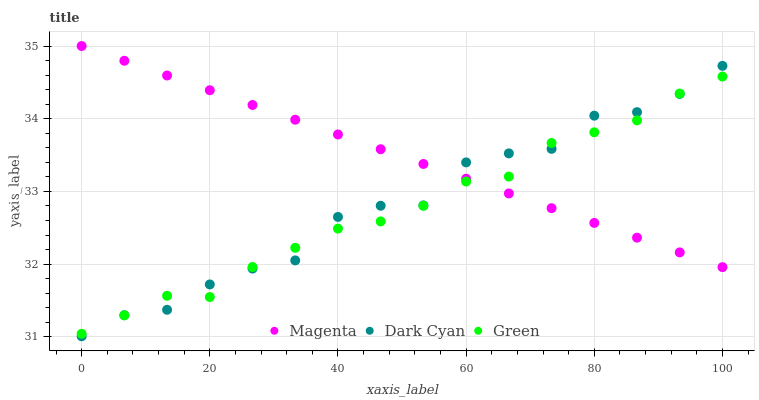Does Green have the minimum area under the curve?
Answer yes or no. Yes. Does Magenta have the maximum area under the curve?
Answer yes or no. Yes. Does Magenta have the minimum area under the curve?
Answer yes or no. No. Does Green have the maximum area under the curve?
Answer yes or no. No. Is Magenta the smoothest?
Answer yes or no. Yes. Is Dark Cyan the roughest?
Answer yes or no. Yes. Is Green the smoothest?
Answer yes or no. No. Is Green the roughest?
Answer yes or no. No. Does Dark Cyan have the lowest value?
Answer yes or no. Yes. Does Green have the lowest value?
Answer yes or no. No. Does Magenta have the highest value?
Answer yes or no. Yes. Does Green have the highest value?
Answer yes or no. No. Does Dark Cyan intersect Magenta?
Answer yes or no. Yes. Is Dark Cyan less than Magenta?
Answer yes or no. No. Is Dark Cyan greater than Magenta?
Answer yes or no. No. 